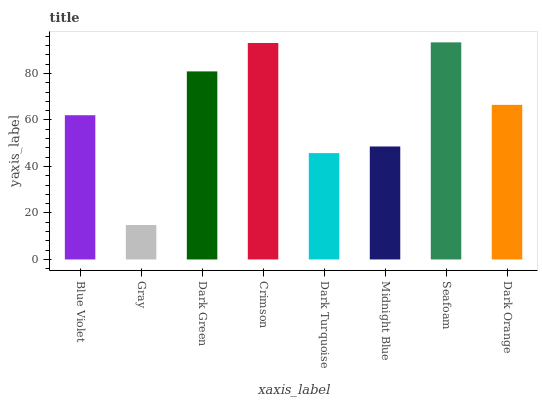Is Gray the minimum?
Answer yes or no. Yes. Is Seafoam the maximum?
Answer yes or no. Yes. Is Dark Green the minimum?
Answer yes or no. No. Is Dark Green the maximum?
Answer yes or no. No. Is Dark Green greater than Gray?
Answer yes or no. Yes. Is Gray less than Dark Green?
Answer yes or no. Yes. Is Gray greater than Dark Green?
Answer yes or no. No. Is Dark Green less than Gray?
Answer yes or no. No. Is Dark Orange the high median?
Answer yes or no. Yes. Is Blue Violet the low median?
Answer yes or no. Yes. Is Crimson the high median?
Answer yes or no. No. Is Seafoam the low median?
Answer yes or no. No. 